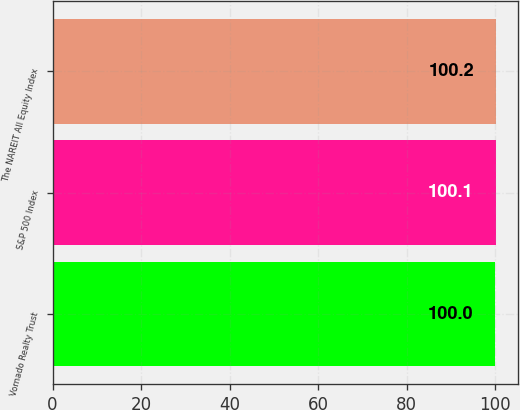Convert chart. <chart><loc_0><loc_0><loc_500><loc_500><bar_chart><fcel>Vornado Realty Trust<fcel>S&P 500 Index<fcel>The NAREIT All Equity Index<nl><fcel>100<fcel>100.1<fcel>100.2<nl></chart> 